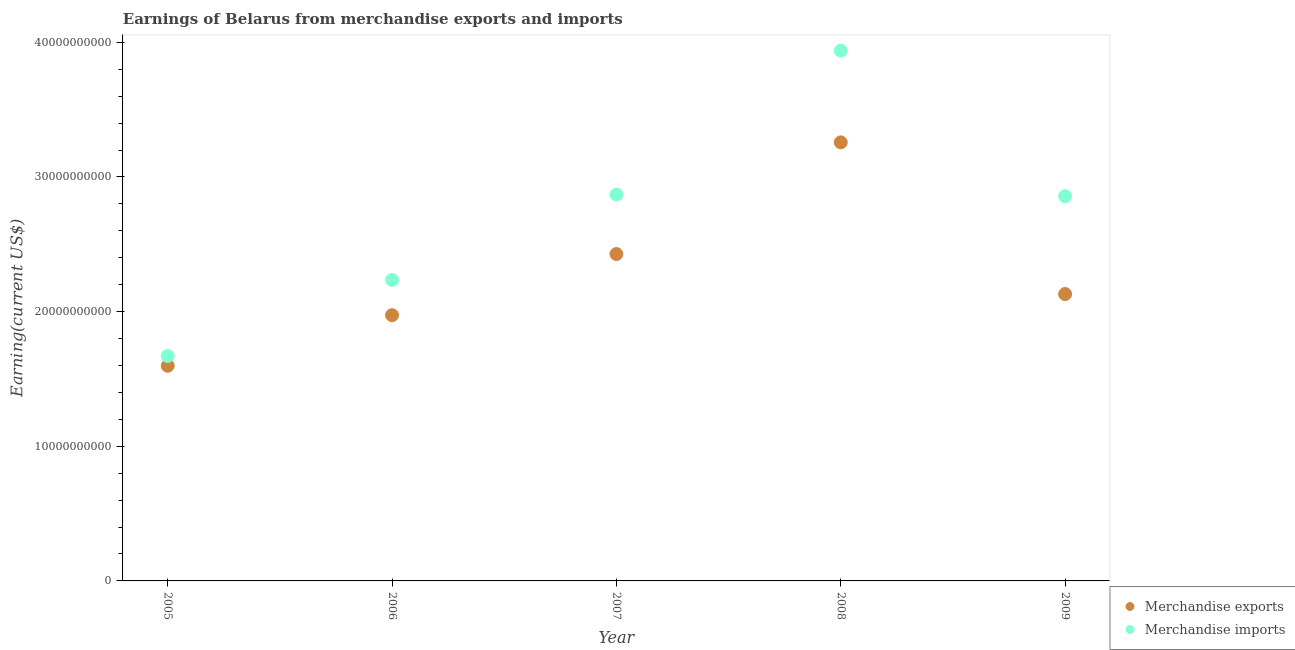What is the earnings from merchandise imports in 2006?
Your response must be concise. 2.24e+1. Across all years, what is the maximum earnings from merchandise exports?
Offer a very short reply. 3.26e+1. Across all years, what is the minimum earnings from merchandise exports?
Offer a terse response. 1.60e+1. In which year was the earnings from merchandise exports maximum?
Offer a very short reply. 2008. What is the total earnings from merchandise exports in the graph?
Offer a terse response. 1.14e+11. What is the difference between the earnings from merchandise imports in 2006 and that in 2008?
Make the answer very short. -1.70e+1. What is the difference between the earnings from merchandise exports in 2007 and the earnings from merchandise imports in 2008?
Provide a succinct answer. -1.51e+1. What is the average earnings from merchandise imports per year?
Ensure brevity in your answer.  2.71e+1. In the year 2008, what is the difference between the earnings from merchandise exports and earnings from merchandise imports?
Provide a short and direct response. -6.81e+09. In how many years, is the earnings from merchandise imports greater than 32000000000 US$?
Your response must be concise. 1. What is the ratio of the earnings from merchandise imports in 2005 to that in 2009?
Keep it short and to the point. 0.58. Is the earnings from merchandise imports in 2005 less than that in 2007?
Give a very brief answer. Yes. Is the difference between the earnings from merchandise imports in 2006 and 2009 greater than the difference between the earnings from merchandise exports in 2006 and 2009?
Make the answer very short. No. What is the difference between the highest and the second highest earnings from merchandise imports?
Keep it short and to the point. 1.07e+1. What is the difference between the highest and the lowest earnings from merchandise imports?
Your answer should be compact. 2.27e+1. In how many years, is the earnings from merchandise imports greater than the average earnings from merchandise imports taken over all years?
Your answer should be very brief. 3. Is the sum of the earnings from merchandise exports in 2006 and 2008 greater than the maximum earnings from merchandise imports across all years?
Make the answer very short. Yes. Does the earnings from merchandise imports monotonically increase over the years?
Provide a succinct answer. No. Is the earnings from merchandise exports strictly greater than the earnings from merchandise imports over the years?
Provide a short and direct response. No. How many dotlines are there?
Offer a very short reply. 2. What is the difference between two consecutive major ticks on the Y-axis?
Your answer should be compact. 1.00e+1. Does the graph contain any zero values?
Offer a terse response. No. Does the graph contain grids?
Your answer should be compact. No. What is the title of the graph?
Provide a succinct answer. Earnings of Belarus from merchandise exports and imports. Does "Ages 15-24" appear as one of the legend labels in the graph?
Make the answer very short. No. What is the label or title of the X-axis?
Provide a short and direct response. Year. What is the label or title of the Y-axis?
Your answer should be very brief. Earning(current US$). What is the Earning(current US$) in Merchandise exports in 2005?
Your answer should be compact. 1.60e+1. What is the Earning(current US$) of Merchandise imports in 2005?
Your answer should be compact. 1.67e+1. What is the Earning(current US$) in Merchandise exports in 2006?
Offer a very short reply. 1.97e+1. What is the Earning(current US$) of Merchandise imports in 2006?
Offer a very short reply. 2.24e+1. What is the Earning(current US$) of Merchandise exports in 2007?
Ensure brevity in your answer.  2.43e+1. What is the Earning(current US$) of Merchandise imports in 2007?
Offer a terse response. 2.87e+1. What is the Earning(current US$) in Merchandise exports in 2008?
Your answer should be compact. 3.26e+1. What is the Earning(current US$) in Merchandise imports in 2008?
Your answer should be compact. 3.94e+1. What is the Earning(current US$) of Merchandise exports in 2009?
Your answer should be compact. 2.13e+1. What is the Earning(current US$) of Merchandise imports in 2009?
Provide a succinct answer. 2.86e+1. Across all years, what is the maximum Earning(current US$) in Merchandise exports?
Your response must be concise. 3.26e+1. Across all years, what is the maximum Earning(current US$) in Merchandise imports?
Keep it short and to the point. 3.94e+1. Across all years, what is the minimum Earning(current US$) of Merchandise exports?
Your response must be concise. 1.60e+1. Across all years, what is the minimum Earning(current US$) of Merchandise imports?
Make the answer very short. 1.67e+1. What is the total Earning(current US$) in Merchandise exports in the graph?
Keep it short and to the point. 1.14e+11. What is the total Earning(current US$) in Merchandise imports in the graph?
Your answer should be compact. 1.36e+11. What is the difference between the Earning(current US$) in Merchandise exports in 2005 and that in 2006?
Offer a terse response. -3.76e+09. What is the difference between the Earning(current US$) of Merchandise imports in 2005 and that in 2006?
Ensure brevity in your answer.  -5.64e+09. What is the difference between the Earning(current US$) in Merchandise exports in 2005 and that in 2007?
Offer a very short reply. -8.30e+09. What is the difference between the Earning(current US$) of Merchandise imports in 2005 and that in 2007?
Your answer should be compact. -1.20e+1. What is the difference between the Earning(current US$) of Merchandise exports in 2005 and that in 2008?
Your response must be concise. -1.66e+1. What is the difference between the Earning(current US$) in Merchandise imports in 2005 and that in 2008?
Give a very brief answer. -2.27e+1. What is the difference between the Earning(current US$) of Merchandise exports in 2005 and that in 2009?
Your response must be concise. -5.33e+09. What is the difference between the Earning(current US$) in Merchandise imports in 2005 and that in 2009?
Ensure brevity in your answer.  -1.19e+1. What is the difference between the Earning(current US$) of Merchandise exports in 2006 and that in 2007?
Provide a short and direct response. -4.54e+09. What is the difference between the Earning(current US$) in Merchandise imports in 2006 and that in 2007?
Your response must be concise. -6.34e+09. What is the difference between the Earning(current US$) of Merchandise exports in 2006 and that in 2008?
Make the answer very short. -1.28e+1. What is the difference between the Earning(current US$) in Merchandise imports in 2006 and that in 2008?
Your answer should be very brief. -1.70e+1. What is the difference between the Earning(current US$) of Merchandise exports in 2006 and that in 2009?
Provide a succinct answer. -1.57e+09. What is the difference between the Earning(current US$) of Merchandise imports in 2006 and that in 2009?
Ensure brevity in your answer.  -6.22e+09. What is the difference between the Earning(current US$) of Merchandise exports in 2007 and that in 2008?
Make the answer very short. -8.30e+09. What is the difference between the Earning(current US$) of Merchandise imports in 2007 and that in 2008?
Ensure brevity in your answer.  -1.07e+1. What is the difference between the Earning(current US$) in Merchandise exports in 2007 and that in 2009?
Make the answer very short. 2.97e+09. What is the difference between the Earning(current US$) in Merchandise imports in 2007 and that in 2009?
Your answer should be very brief. 1.24e+08. What is the difference between the Earning(current US$) of Merchandise exports in 2008 and that in 2009?
Ensure brevity in your answer.  1.13e+1. What is the difference between the Earning(current US$) in Merchandise imports in 2008 and that in 2009?
Ensure brevity in your answer.  1.08e+1. What is the difference between the Earning(current US$) of Merchandise exports in 2005 and the Earning(current US$) of Merchandise imports in 2006?
Ensure brevity in your answer.  -6.37e+09. What is the difference between the Earning(current US$) of Merchandise exports in 2005 and the Earning(current US$) of Merchandise imports in 2007?
Offer a terse response. -1.27e+1. What is the difference between the Earning(current US$) in Merchandise exports in 2005 and the Earning(current US$) in Merchandise imports in 2008?
Your response must be concise. -2.34e+1. What is the difference between the Earning(current US$) of Merchandise exports in 2005 and the Earning(current US$) of Merchandise imports in 2009?
Ensure brevity in your answer.  -1.26e+1. What is the difference between the Earning(current US$) of Merchandise exports in 2006 and the Earning(current US$) of Merchandise imports in 2007?
Offer a terse response. -8.96e+09. What is the difference between the Earning(current US$) in Merchandise exports in 2006 and the Earning(current US$) in Merchandise imports in 2008?
Your answer should be very brief. -1.96e+1. What is the difference between the Earning(current US$) in Merchandise exports in 2006 and the Earning(current US$) in Merchandise imports in 2009?
Your answer should be very brief. -8.84e+09. What is the difference between the Earning(current US$) of Merchandise exports in 2007 and the Earning(current US$) of Merchandise imports in 2008?
Ensure brevity in your answer.  -1.51e+1. What is the difference between the Earning(current US$) in Merchandise exports in 2007 and the Earning(current US$) in Merchandise imports in 2009?
Make the answer very short. -4.29e+09. What is the difference between the Earning(current US$) in Merchandise exports in 2008 and the Earning(current US$) in Merchandise imports in 2009?
Your answer should be compact. 4.00e+09. What is the average Earning(current US$) of Merchandise exports per year?
Your response must be concise. 2.28e+1. What is the average Earning(current US$) in Merchandise imports per year?
Ensure brevity in your answer.  2.71e+1. In the year 2005, what is the difference between the Earning(current US$) in Merchandise exports and Earning(current US$) in Merchandise imports?
Your answer should be very brief. -7.29e+08. In the year 2006, what is the difference between the Earning(current US$) of Merchandise exports and Earning(current US$) of Merchandise imports?
Your response must be concise. -2.62e+09. In the year 2007, what is the difference between the Earning(current US$) in Merchandise exports and Earning(current US$) in Merchandise imports?
Your response must be concise. -4.42e+09. In the year 2008, what is the difference between the Earning(current US$) in Merchandise exports and Earning(current US$) in Merchandise imports?
Your response must be concise. -6.81e+09. In the year 2009, what is the difference between the Earning(current US$) in Merchandise exports and Earning(current US$) in Merchandise imports?
Provide a succinct answer. -7.26e+09. What is the ratio of the Earning(current US$) in Merchandise exports in 2005 to that in 2006?
Ensure brevity in your answer.  0.81. What is the ratio of the Earning(current US$) in Merchandise imports in 2005 to that in 2006?
Your answer should be very brief. 0.75. What is the ratio of the Earning(current US$) in Merchandise exports in 2005 to that in 2007?
Your response must be concise. 0.66. What is the ratio of the Earning(current US$) of Merchandise imports in 2005 to that in 2007?
Your response must be concise. 0.58. What is the ratio of the Earning(current US$) of Merchandise exports in 2005 to that in 2008?
Give a very brief answer. 0.49. What is the ratio of the Earning(current US$) in Merchandise imports in 2005 to that in 2008?
Your answer should be very brief. 0.42. What is the ratio of the Earning(current US$) in Merchandise exports in 2005 to that in 2009?
Your answer should be compact. 0.75. What is the ratio of the Earning(current US$) in Merchandise imports in 2005 to that in 2009?
Ensure brevity in your answer.  0.58. What is the ratio of the Earning(current US$) in Merchandise exports in 2006 to that in 2007?
Provide a succinct answer. 0.81. What is the ratio of the Earning(current US$) of Merchandise imports in 2006 to that in 2007?
Your answer should be very brief. 0.78. What is the ratio of the Earning(current US$) of Merchandise exports in 2006 to that in 2008?
Offer a terse response. 0.61. What is the ratio of the Earning(current US$) of Merchandise imports in 2006 to that in 2008?
Your answer should be very brief. 0.57. What is the ratio of the Earning(current US$) of Merchandise exports in 2006 to that in 2009?
Provide a short and direct response. 0.93. What is the ratio of the Earning(current US$) in Merchandise imports in 2006 to that in 2009?
Your answer should be compact. 0.78. What is the ratio of the Earning(current US$) in Merchandise exports in 2007 to that in 2008?
Your answer should be very brief. 0.75. What is the ratio of the Earning(current US$) in Merchandise imports in 2007 to that in 2008?
Make the answer very short. 0.73. What is the ratio of the Earning(current US$) of Merchandise exports in 2007 to that in 2009?
Ensure brevity in your answer.  1.14. What is the ratio of the Earning(current US$) in Merchandise exports in 2008 to that in 2009?
Provide a succinct answer. 1.53. What is the ratio of the Earning(current US$) of Merchandise imports in 2008 to that in 2009?
Ensure brevity in your answer.  1.38. What is the difference between the highest and the second highest Earning(current US$) in Merchandise exports?
Your answer should be compact. 8.30e+09. What is the difference between the highest and the second highest Earning(current US$) in Merchandise imports?
Your answer should be compact. 1.07e+1. What is the difference between the highest and the lowest Earning(current US$) in Merchandise exports?
Your answer should be compact. 1.66e+1. What is the difference between the highest and the lowest Earning(current US$) in Merchandise imports?
Your answer should be very brief. 2.27e+1. 